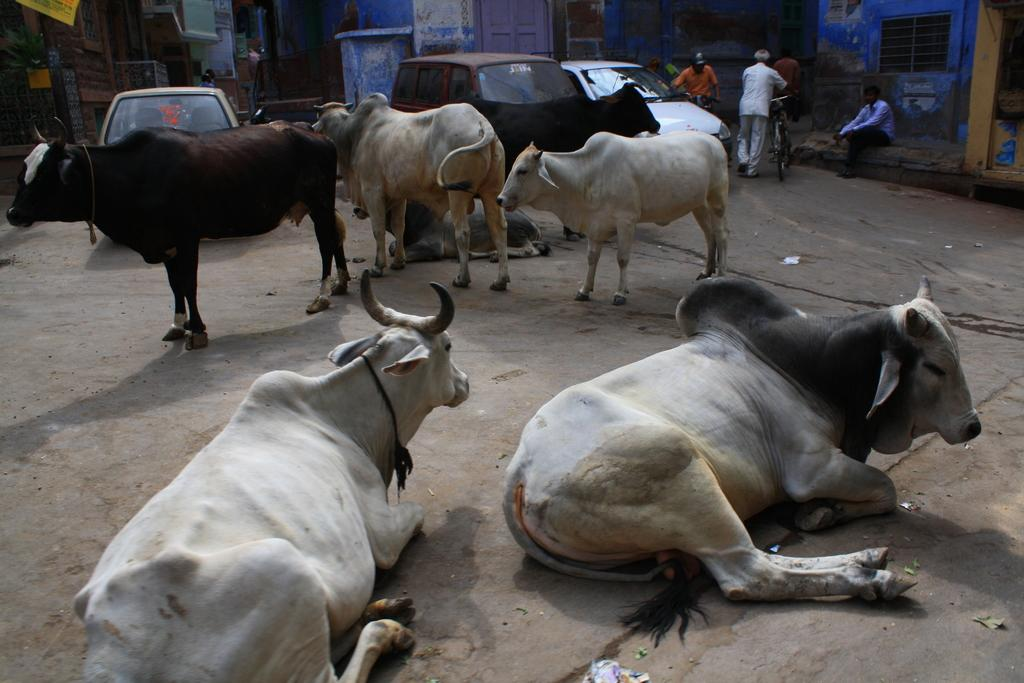What types of living organisms can be seen in the image? There are animals in the image. What else can be seen in the image besides animals? There are vehicles in the image. Where are the persons wearing clothes located in the image? The persons wearing clothes can be found in the top right of the image. What type of structures are visible at the top of the image? There are buildings at the top of the image. What type of store can be seen in the image? There is no store present in the image. What is the stove used for in the image? There is no stove present in the image. 